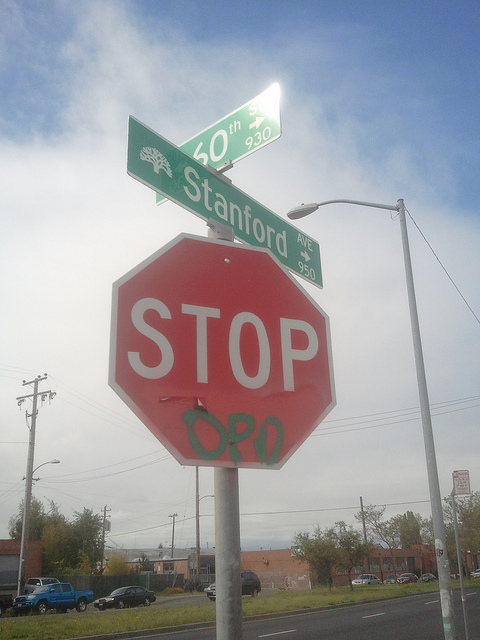<image>What song is the sign and the graffiti referring to? I don't know what song the sign and the graffiti are referring to. It could be 'opo', 'stop', 'shining all', 'stop opo', or something else entirely. What song is the sign and the graffiti referring to? I don't know the song that the sign and graffiti are referring to. It could be 'opo', 'stop', 'stop opo' or something else. 